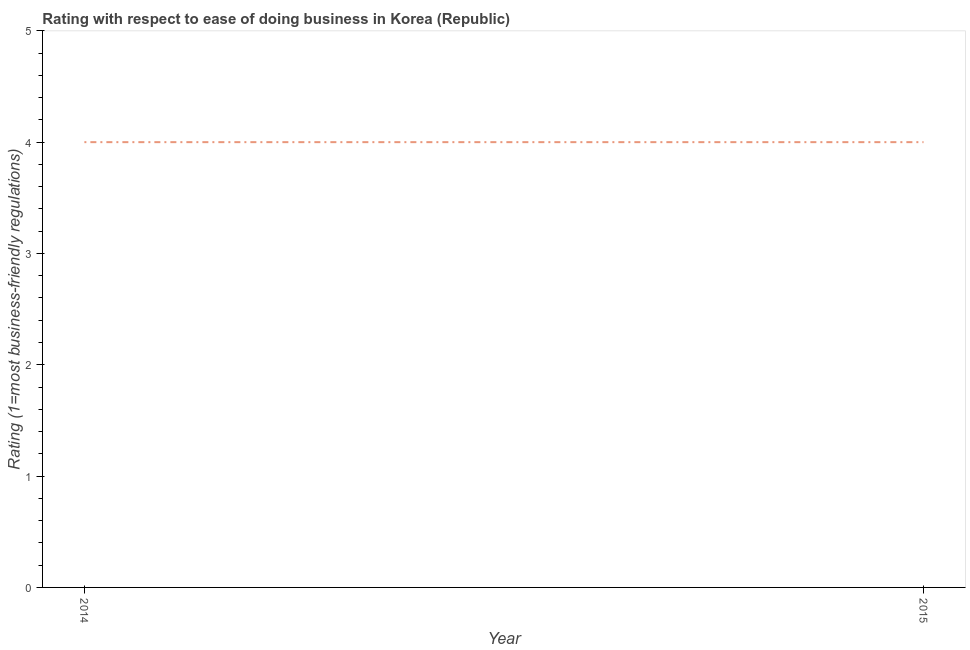What is the ease of doing business index in 2015?
Your answer should be very brief. 4. Across all years, what is the maximum ease of doing business index?
Provide a succinct answer. 4. Across all years, what is the minimum ease of doing business index?
Make the answer very short. 4. In which year was the ease of doing business index maximum?
Offer a very short reply. 2014. What is the sum of the ease of doing business index?
Your answer should be very brief. 8. What is the difference between the ease of doing business index in 2014 and 2015?
Your answer should be compact. 0. Does the ease of doing business index monotonically increase over the years?
Provide a succinct answer. No. How many lines are there?
Provide a succinct answer. 1. How many years are there in the graph?
Offer a very short reply. 2. What is the title of the graph?
Your answer should be compact. Rating with respect to ease of doing business in Korea (Republic). What is the label or title of the X-axis?
Your response must be concise. Year. What is the label or title of the Y-axis?
Offer a terse response. Rating (1=most business-friendly regulations). 